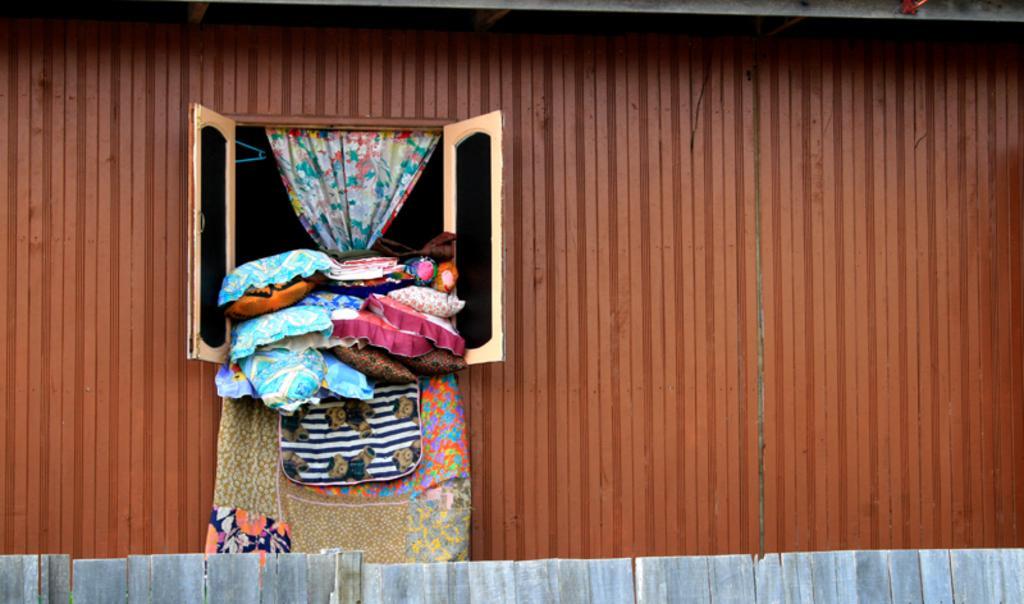Could you give a brief overview of what you see in this image? In this image, we can see a window to a shed and there are pillows, clothes and we can see a curtain. At the bottom, there is a fence. 